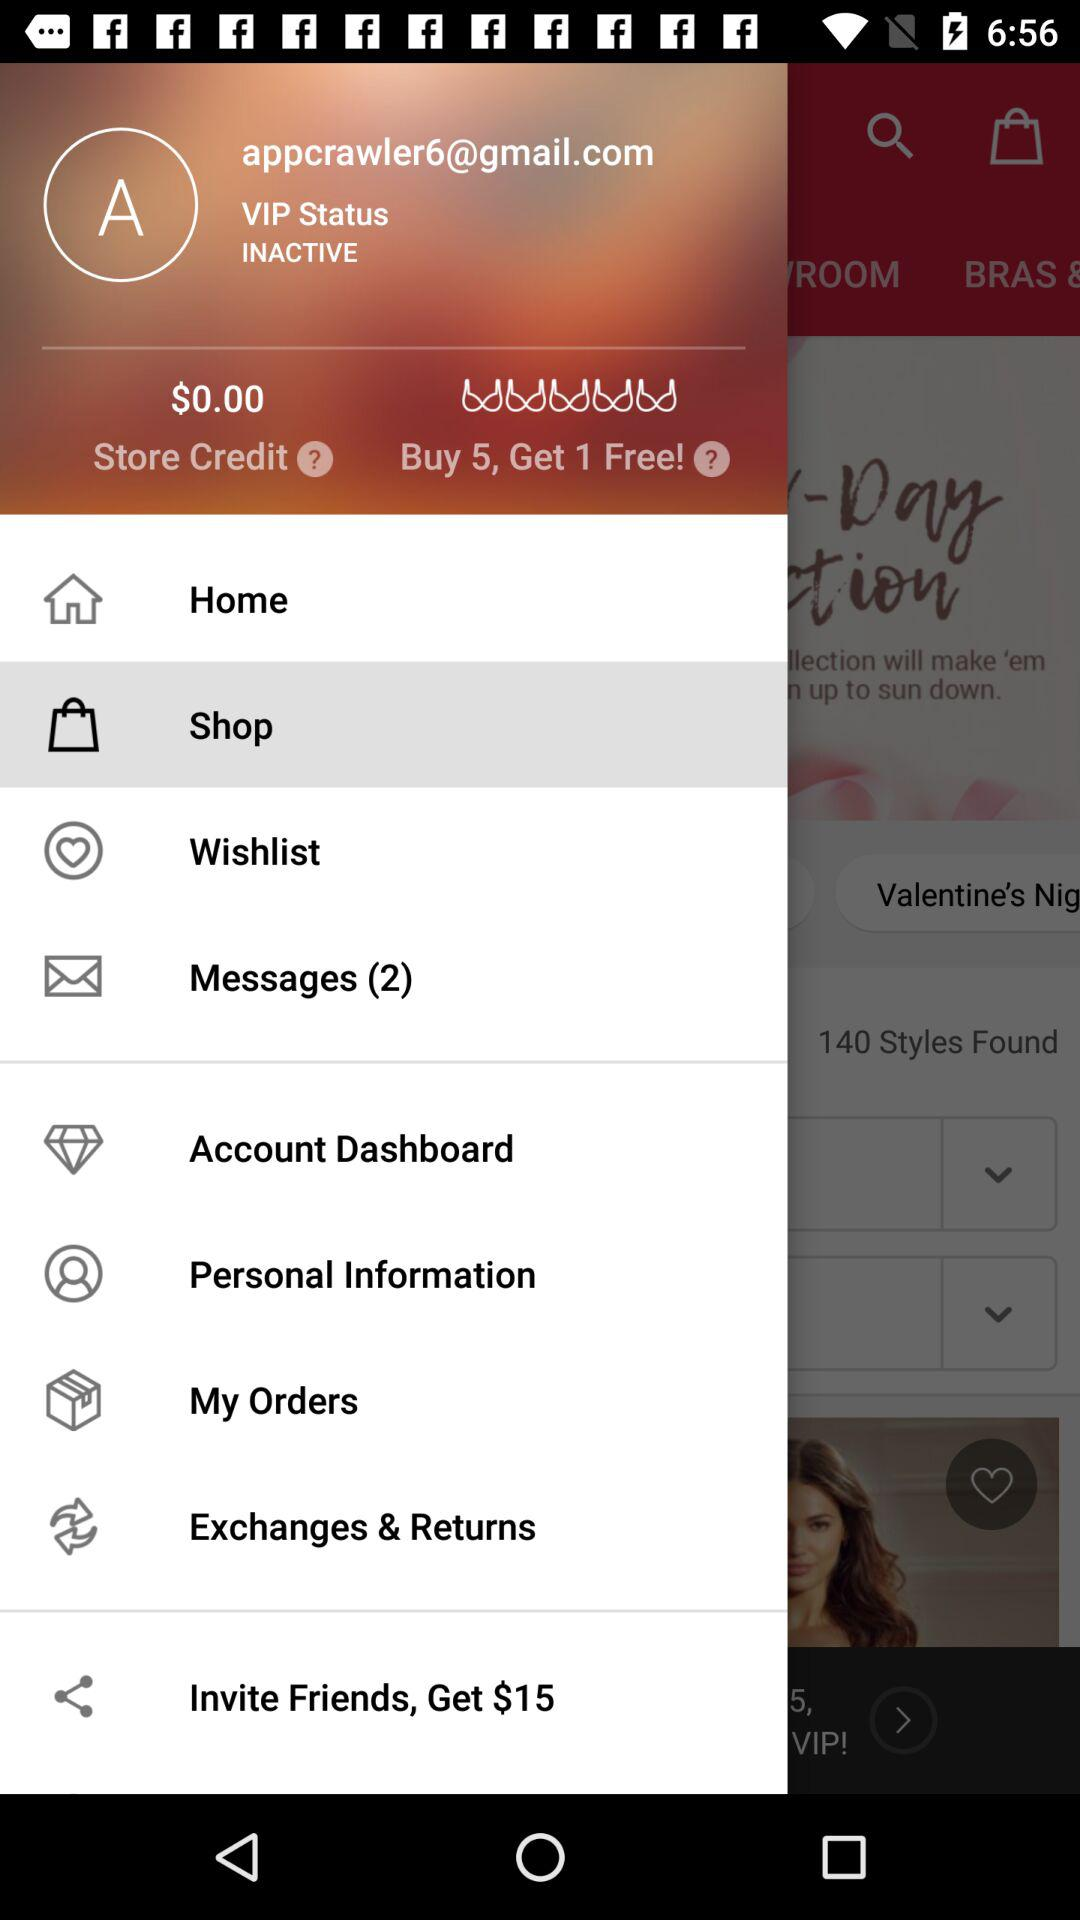What is price we get on inviting friends to this application? The price you get is $15. 